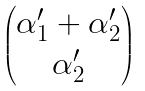Convert formula to latex. <formula><loc_0><loc_0><loc_500><loc_500>\begin{pmatrix} \alpha ^ { \prime } _ { 1 } + \alpha ^ { \prime } _ { 2 } \\ \alpha ^ { \prime } _ { 2 } \end{pmatrix}</formula> 